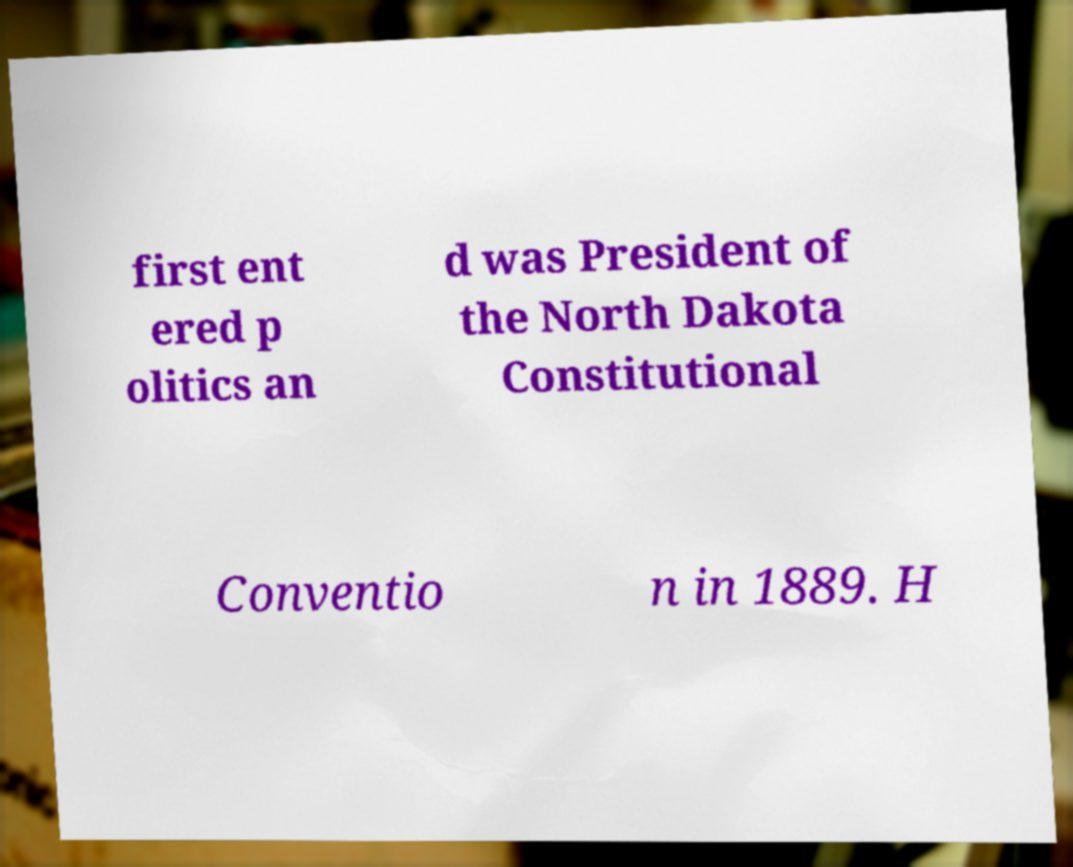Can you read and provide the text displayed in the image?This photo seems to have some interesting text. Can you extract and type it out for me? first ent ered p olitics an d was President of the North Dakota Constitutional Conventio n in 1889. H 